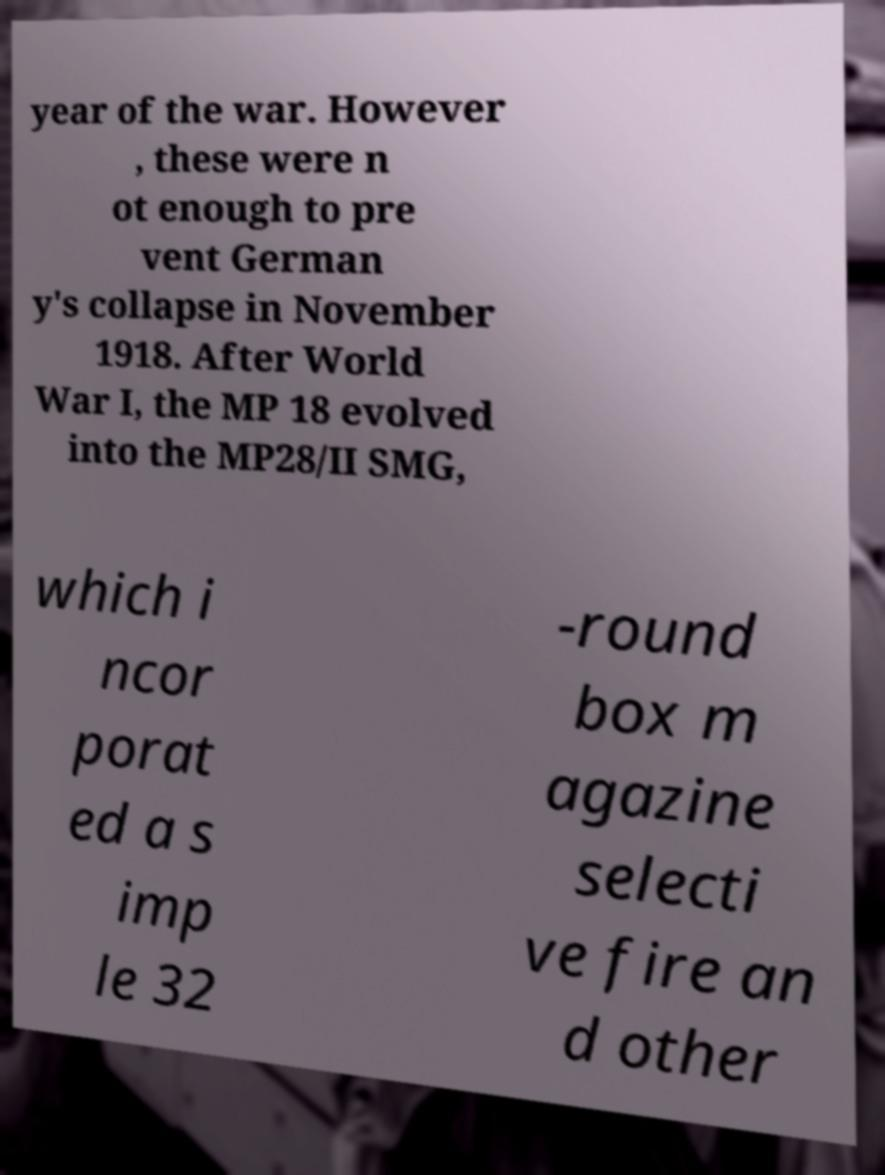Could you extract and type out the text from this image? year of the war. However , these were n ot enough to pre vent German y's collapse in November 1918. After World War I, the MP 18 evolved into the MP28/II SMG, which i ncor porat ed a s imp le 32 -round box m agazine selecti ve fire an d other 